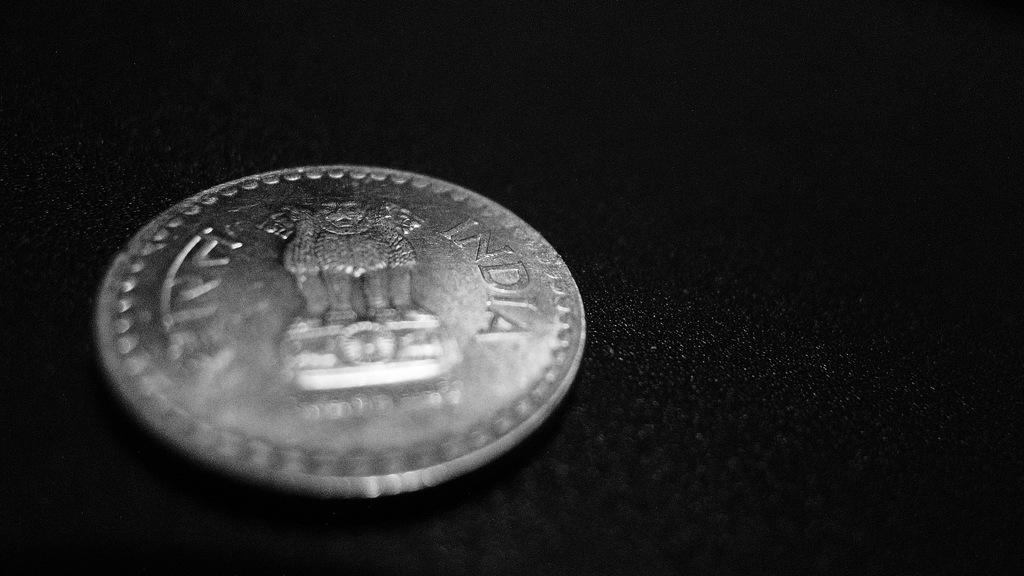Provide a one-sentence caption for the provided image. The back of a coin says that it is from India. 